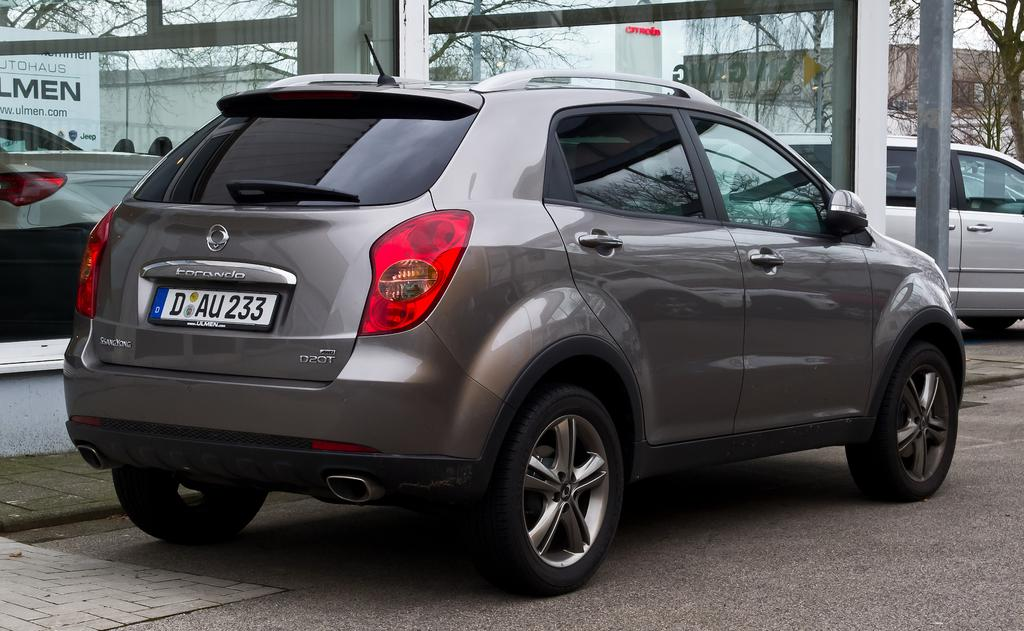What can be seen on the road in the image? There are vehicles on the road in the image. What type of architectural feature is present in the background of the image? There are glass doors and buildings visible in the background of the image. What type of natural elements can be seen in the background of the image? There are trees in the background of the image. What type of structures are present in the image? There are poles in the image. Can you see any giants walking through the trees in the image? There are no giants present in the image; it features vehicles on the road, glass doors, buildings, trees, and poles. What type of flame can be seen coming from the poles in the image? There are no flames present on the poles in the image. 